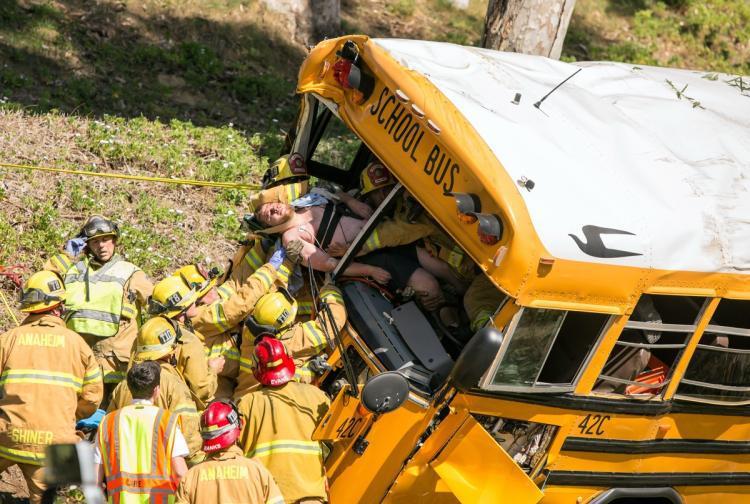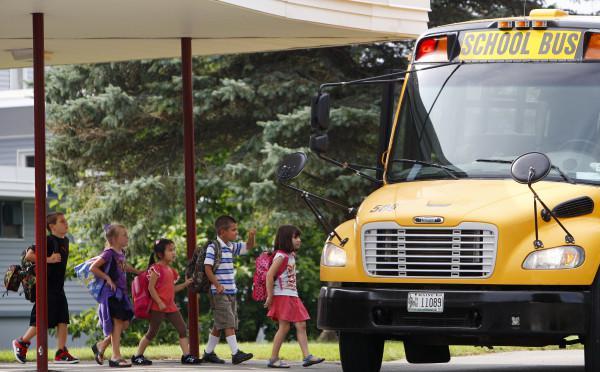The first image is the image on the left, the second image is the image on the right. For the images shown, is this caption "News headline is visible at bottom of photo for at least one image." true? Answer yes or no. No. The first image is the image on the left, the second image is the image on the right. Examine the images to the left and right. Is the description "There is 2 school busses shown." accurate? Answer yes or no. Yes. 